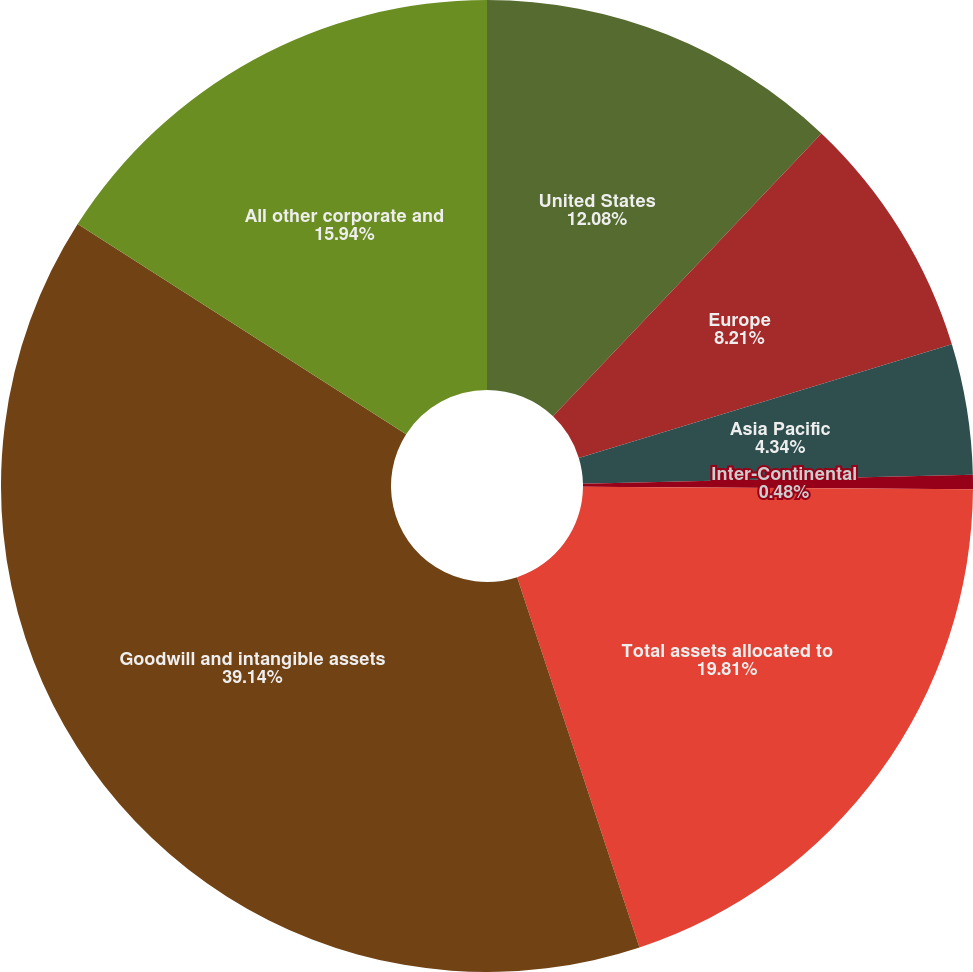<chart> <loc_0><loc_0><loc_500><loc_500><pie_chart><fcel>United States<fcel>Europe<fcel>Asia Pacific<fcel>Inter-Continental<fcel>Total assets allocated to<fcel>Goodwill and intangible assets<fcel>All other corporate and<nl><fcel>12.08%<fcel>8.21%<fcel>4.34%<fcel>0.48%<fcel>19.81%<fcel>39.14%<fcel>15.94%<nl></chart> 